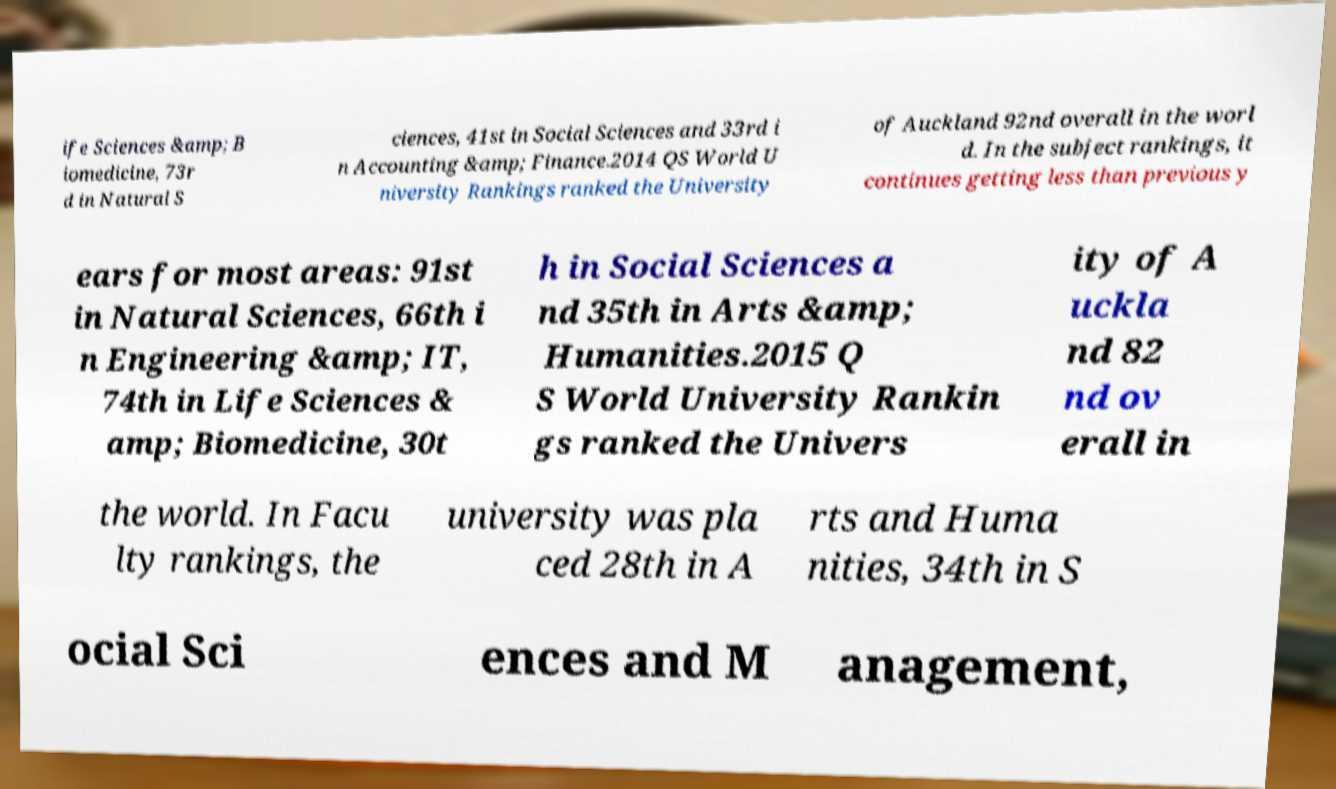Could you extract and type out the text from this image? ife Sciences &amp; B iomedicine, 73r d in Natural S ciences, 41st in Social Sciences and 33rd i n Accounting &amp; Finance.2014 QS World U niversity Rankings ranked the University of Auckland 92nd overall in the worl d. In the subject rankings, it continues getting less than previous y ears for most areas: 91st in Natural Sciences, 66th i n Engineering &amp; IT, 74th in Life Sciences & amp; Biomedicine, 30t h in Social Sciences a nd 35th in Arts &amp; Humanities.2015 Q S World University Rankin gs ranked the Univers ity of A uckla nd 82 nd ov erall in the world. In Facu lty rankings, the university was pla ced 28th in A rts and Huma nities, 34th in S ocial Sci ences and M anagement, 